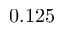<formula> <loc_0><loc_0><loc_500><loc_500>0 . 1 2 5</formula> 